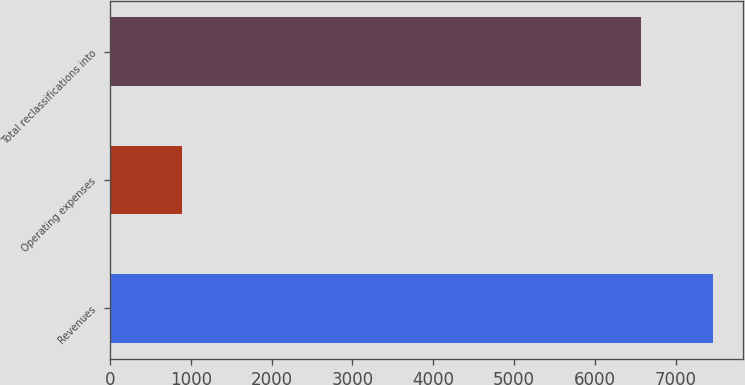Convert chart to OTSL. <chart><loc_0><loc_0><loc_500><loc_500><bar_chart><fcel>Revenues<fcel>Operating expenses<fcel>Total reclassifications into<nl><fcel>7457<fcel>892<fcel>6565<nl></chart> 